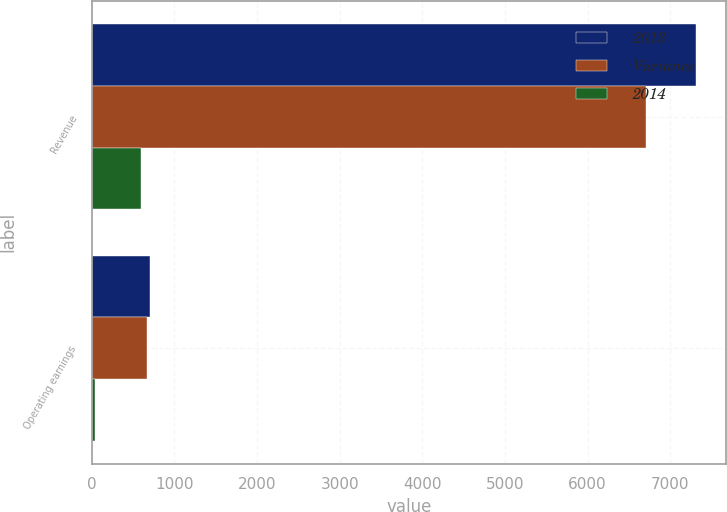Convert chart. <chart><loc_0><loc_0><loc_500><loc_500><stacked_bar_chart><ecel><fcel>Revenue<fcel>Operating earnings<nl><fcel>2013<fcel>7312<fcel>703<nl><fcel>Variance<fcel>6712<fcel>666<nl><fcel>2014<fcel>600<fcel>37<nl></chart> 